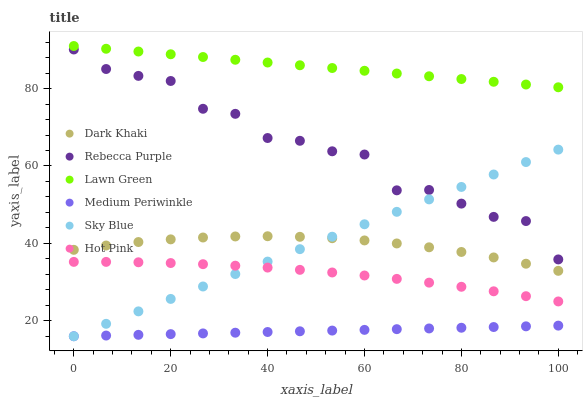Does Medium Periwinkle have the minimum area under the curve?
Answer yes or no. Yes. Does Lawn Green have the maximum area under the curve?
Answer yes or no. Yes. Does Hot Pink have the minimum area under the curve?
Answer yes or no. No. Does Hot Pink have the maximum area under the curve?
Answer yes or no. No. Is Medium Periwinkle the smoothest?
Answer yes or no. Yes. Is Rebecca Purple the roughest?
Answer yes or no. Yes. Is Hot Pink the smoothest?
Answer yes or no. No. Is Hot Pink the roughest?
Answer yes or no. No. Does Medium Periwinkle have the lowest value?
Answer yes or no. Yes. Does Hot Pink have the lowest value?
Answer yes or no. No. Does Lawn Green have the highest value?
Answer yes or no. Yes. Does Hot Pink have the highest value?
Answer yes or no. No. Is Dark Khaki less than Rebecca Purple?
Answer yes or no. Yes. Is Lawn Green greater than Dark Khaki?
Answer yes or no. Yes. Does Medium Periwinkle intersect Sky Blue?
Answer yes or no. Yes. Is Medium Periwinkle less than Sky Blue?
Answer yes or no. No. Is Medium Periwinkle greater than Sky Blue?
Answer yes or no. No. Does Dark Khaki intersect Rebecca Purple?
Answer yes or no. No. 